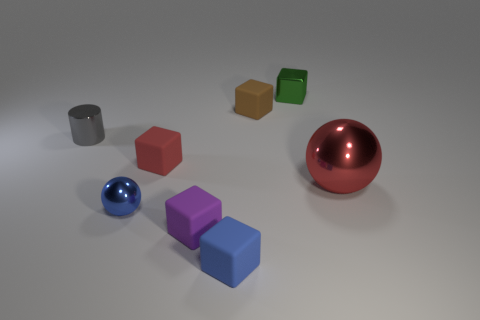Is there a block that has the same size as the red metallic thing?
Make the answer very short. No. There is a rubber block that is left of the purple matte thing; does it have the same color as the tiny metallic sphere?
Keep it short and to the point. No. What number of purple objects are either blocks or big balls?
Your answer should be compact. 1. What number of tiny balls have the same color as the metal block?
Offer a very short reply. 0. Is the material of the large red sphere the same as the small red thing?
Keep it short and to the point. No. There is a metallic sphere that is right of the tiny blue sphere; what number of brown rubber cubes are to the right of it?
Keep it short and to the point. 0. Do the brown rubber object and the red metal sphere have the same size?
Make the answer very short. No. What number of blue blocks have the same material as the green object?
Your answer should be very brief. 0. There is a red object that is the same shape as the green object; what size is it?
Your answer should be very brief. Small. There is a red thing to the left of the big red metallic object; is its shape the same as the large object?
Ensure brevity in your answer.  No. 